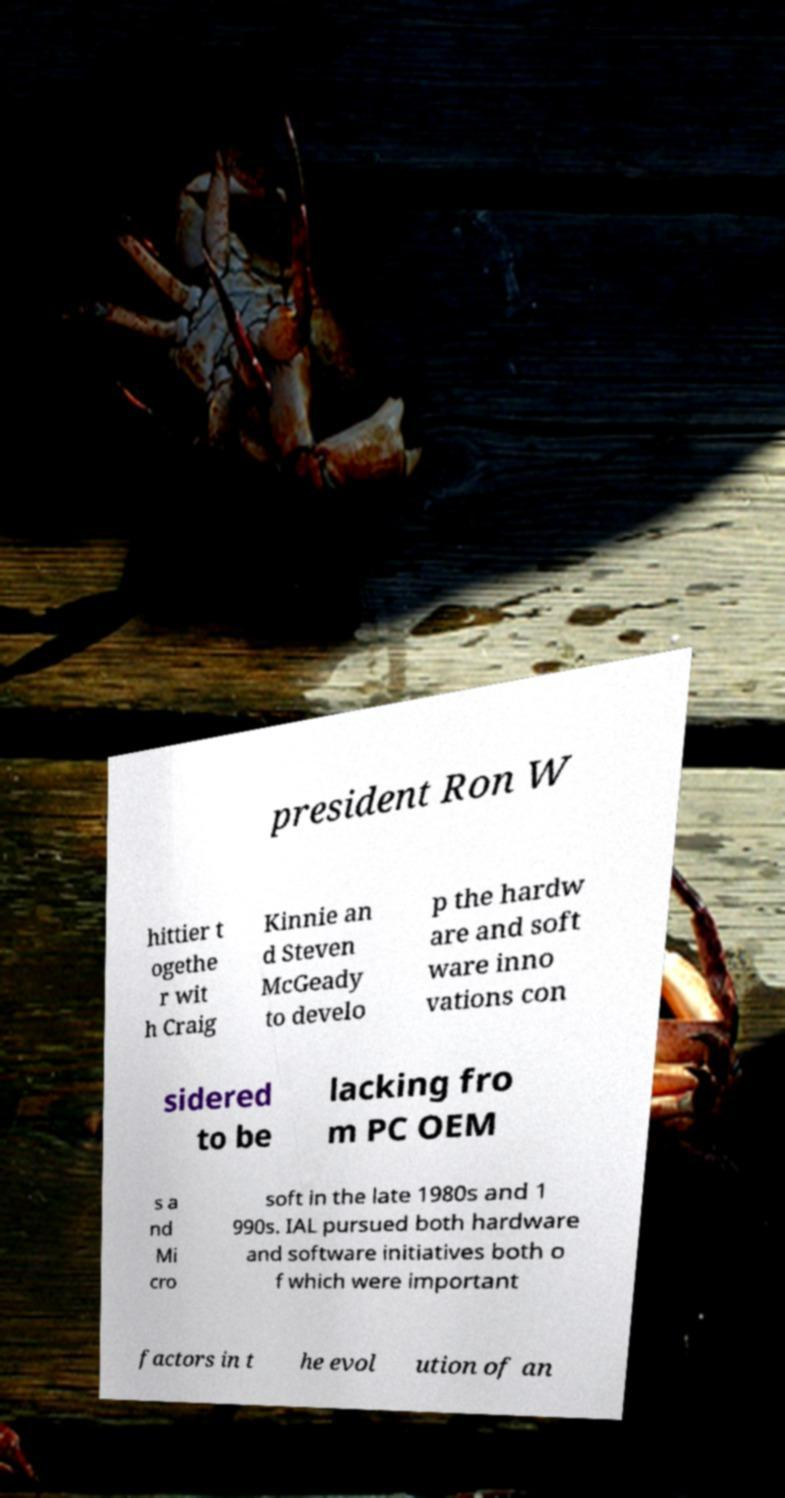I need the written content from this picture converted into text. Can you do that? president Ron W hittier t ogethe r wit h Craig Kinnie an d Steven McGeady to develo p the hardw are and soft ware inno vations con sidered to be lacking fro m PC OEM s a nd Mi cro soft in the late 1980s and 1 990s. IAL pursued both hardware and software initiatives both o f which were important factors in t he evol ution of an 